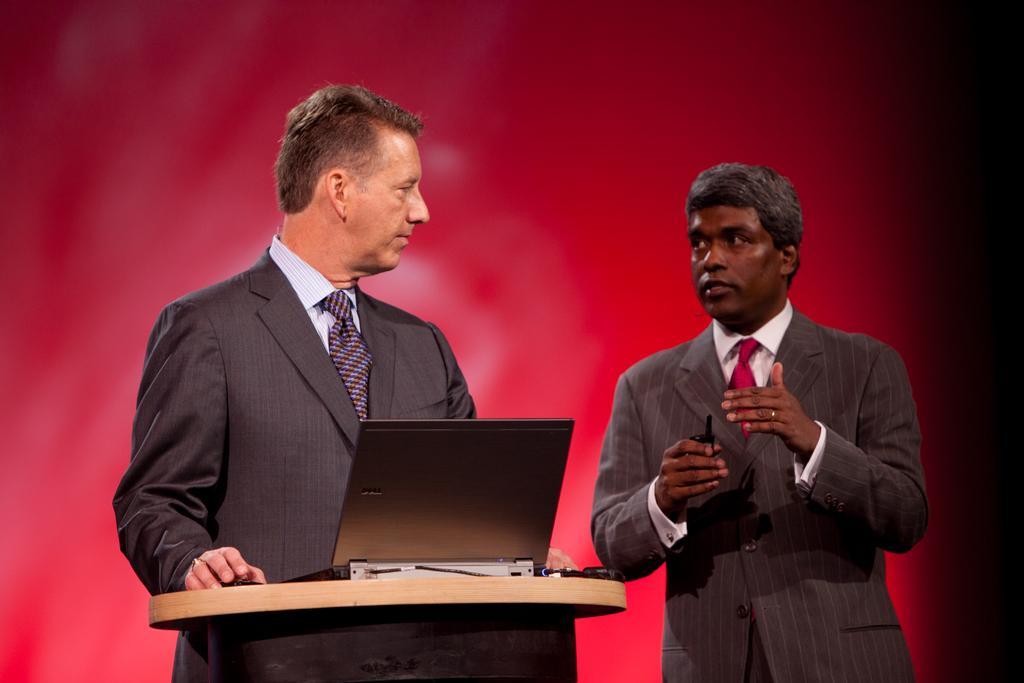In one or two sentences, can you explain what this image depicts? In this image we can see two men are standing at the podium. On the podium we can see a laptop and cables. In the background we can see red color object. 